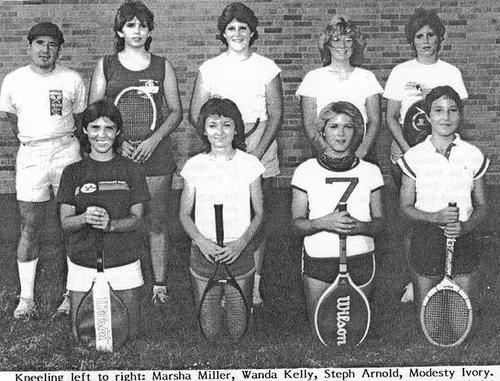How many people are in this photo?
Give a very brief answer. 9. How many tennis rackets can you see?
Give a very brief answer. 4. How many people are there?
Give a very brief answer. 9. 